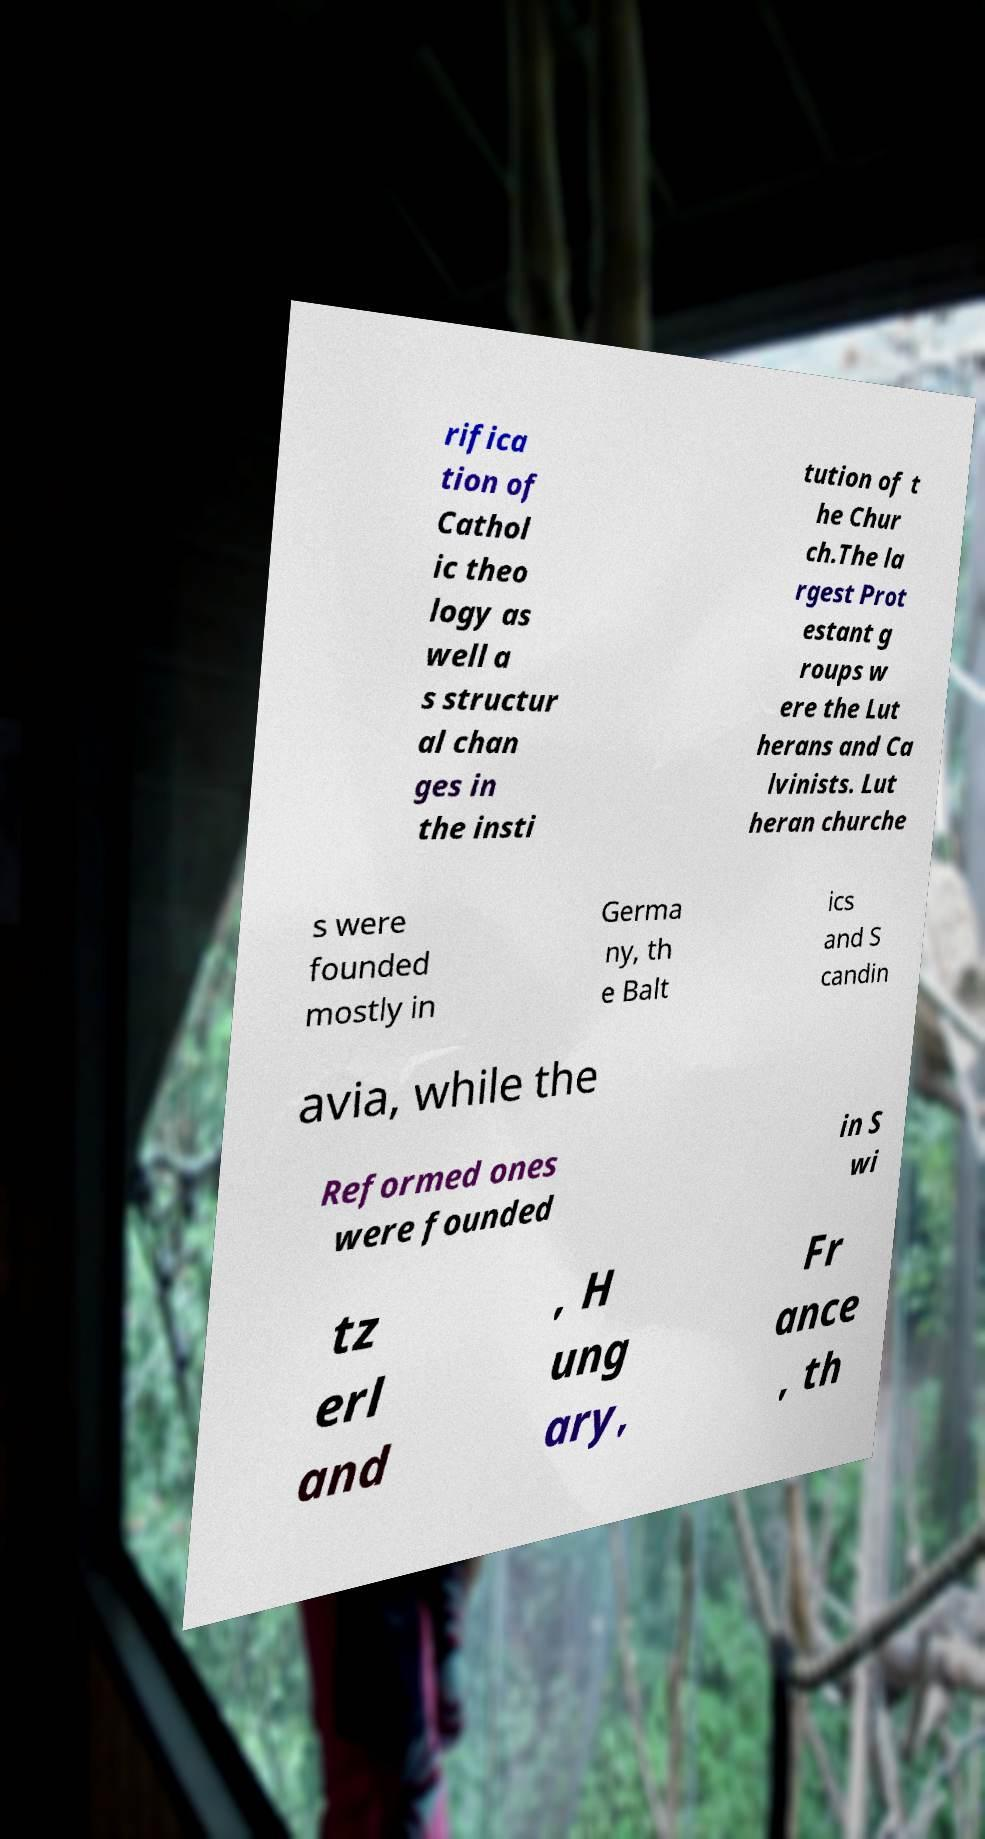I need the written content from this picture converted into text. Can you do that? rifica tion of Cathol ic theo logy as well a s structur al chan ges in the insti tution of t he Chur ch.The la rgest Prot estant g roups w ere the Lut herans and Ca lvinists. Lut heran churche s were founded mostly in Germa ny, th e Balt ics and S candin avia, while the Reformed ones were founded in S wi tz erl and , H ung ary, Fr ance , th 